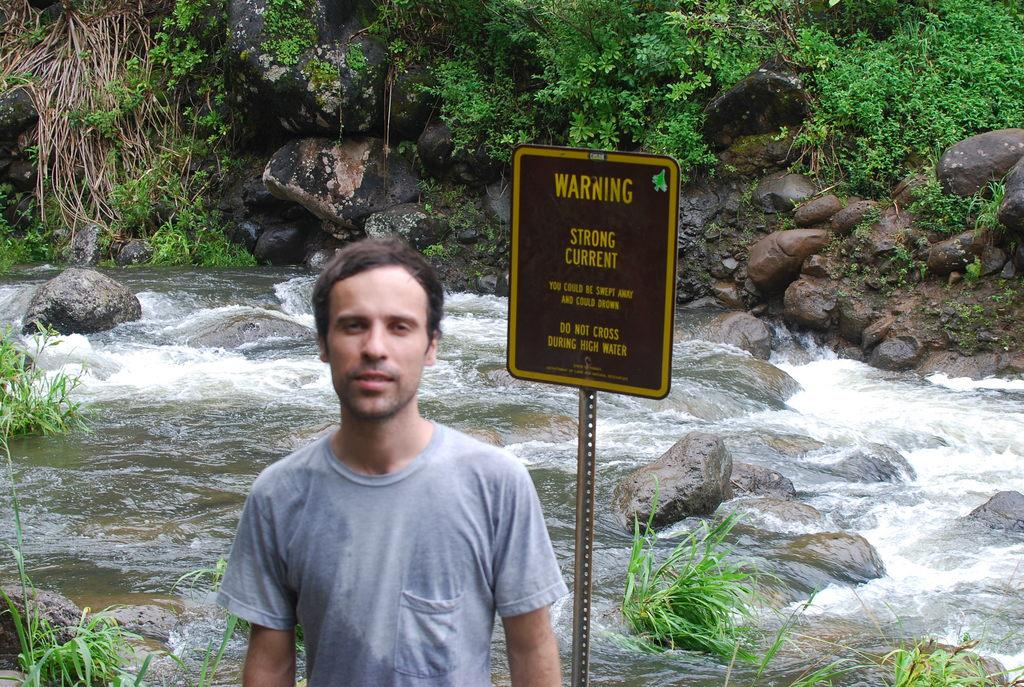Who is present in the image? There is a man in the image. What can be seen in the background of the image? There is a board, rocks, and plants in the background of the image. What is visible at the bottom of the image? There is water visible at the bottom of the image. How many pizzas can be seen in the image? There are no pizzas present in the image. What time of day is it in the image, based on the hour? The provided facts do not mention the time of day or any specific hour, so it cannot be determined from the image. 